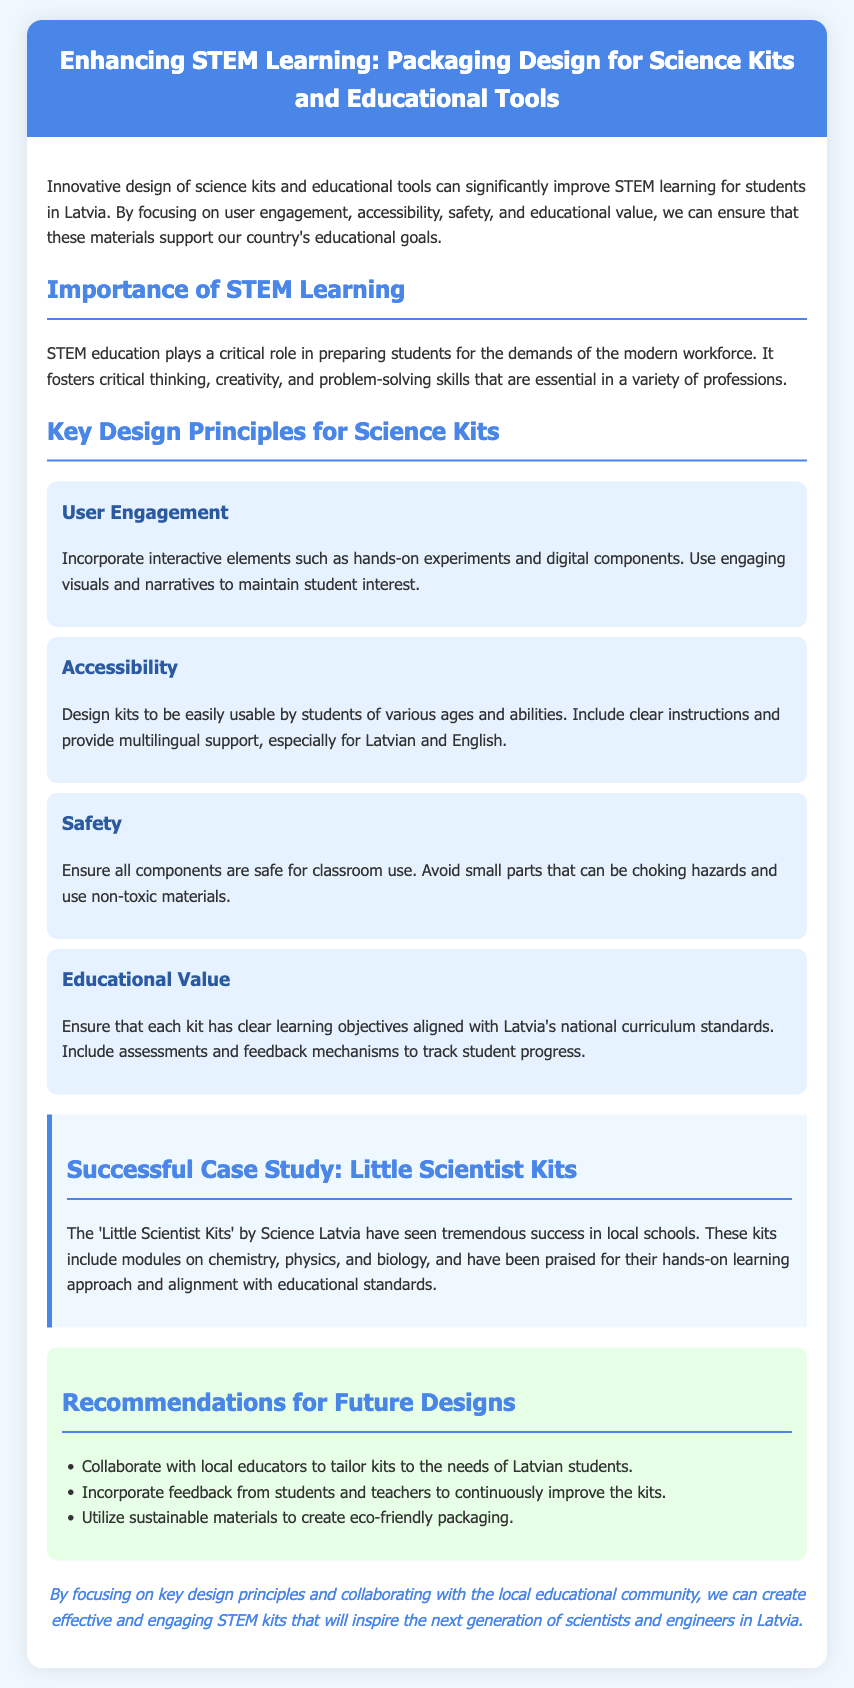What is the title of the document? The title is provided in the header of the document.
Answer: Enhancing STEM Learning: Packaging Design for Science Kits and Educational Tools What organization has created the successful case study mentioned? The successful case study discusses "Little Scientist Kits" by Science Latvia.
Answer: Science Latvia What are two key aspects of user engagement mentioned in the design principles? The document mentions incorporating interactive elements and engaging visuals.
Answer: Interactive elements and engaging visuals What is one of the recommendations for future designs? The recommendations section lists multiple suggestions for improving future designs of science kits.
Answer: Collaborate with local educators How many design principles for science kits are listed? The document outlines four key design principles in its content.
Answer: Four What safety guideline is emphasized in the document? The document specifies a recommendation regarding safety in using materials for classroom kits.
Answer: Non-toxic materials What is the primary purpose of STEM education according to the document? The document presents the significance of STEM education in preparing students for the workforce.
Answer: Preparing students for the workforce Which two languages should the instructions support according to the accessibility principle? The document states the importance of providing instructions in specific languages.
Answer: Latvian and English What is the background color of the recommendations section? The document describes the design of the recommendations section, including its color.
Answer: E6ffe6 